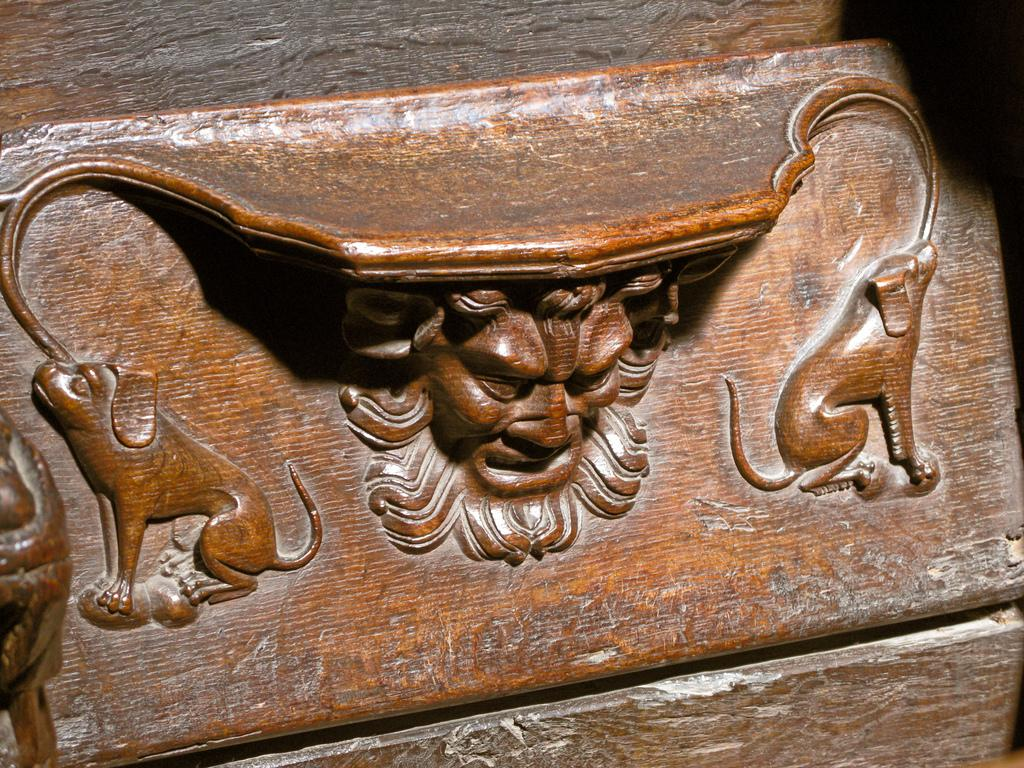What is the main subject of the image? The main subject of the image is a carving of wood. What is the color of the wood in the image? The wood is in brown color. What type of neck accessory is depicted in the wood carving? There is no neck accessory depicted in the wood carving; it is a standalone carving. What type of invention is showcased in the wood carving? There is no invention showcased in the wood carving; it is a carving of wood without any specific context or purpose. 